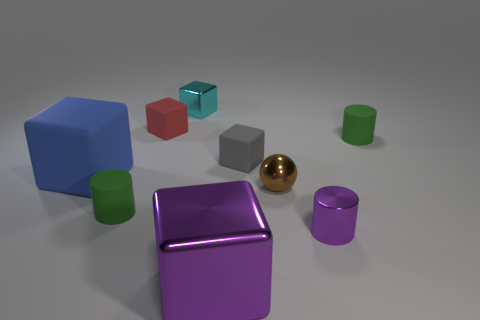Subtract 1 cubes. How many cubes are left? 4 Subtract all purple blocks. How many blocks are left? 4 Subtract all cyan cubes. How many cubes are left? 4 Subtract all green cubes. Subtract all brown balls. How many cubes are left? 5 Add 1 tiny green cylinders. How many objects exist? 10 Subtract all blocks. How many objects are left? 4 Add 9 tiny cyan metallic things. How many tiny cyan metallic things are left? 10 Add 1 blue metallic cylinders. How many blue metallic cylinders exist? 1 Subtract 0 purple balls. How many objects are left? 9 Subtract all brown objects. Subtract all gray blocks. How many objects are left? 7 